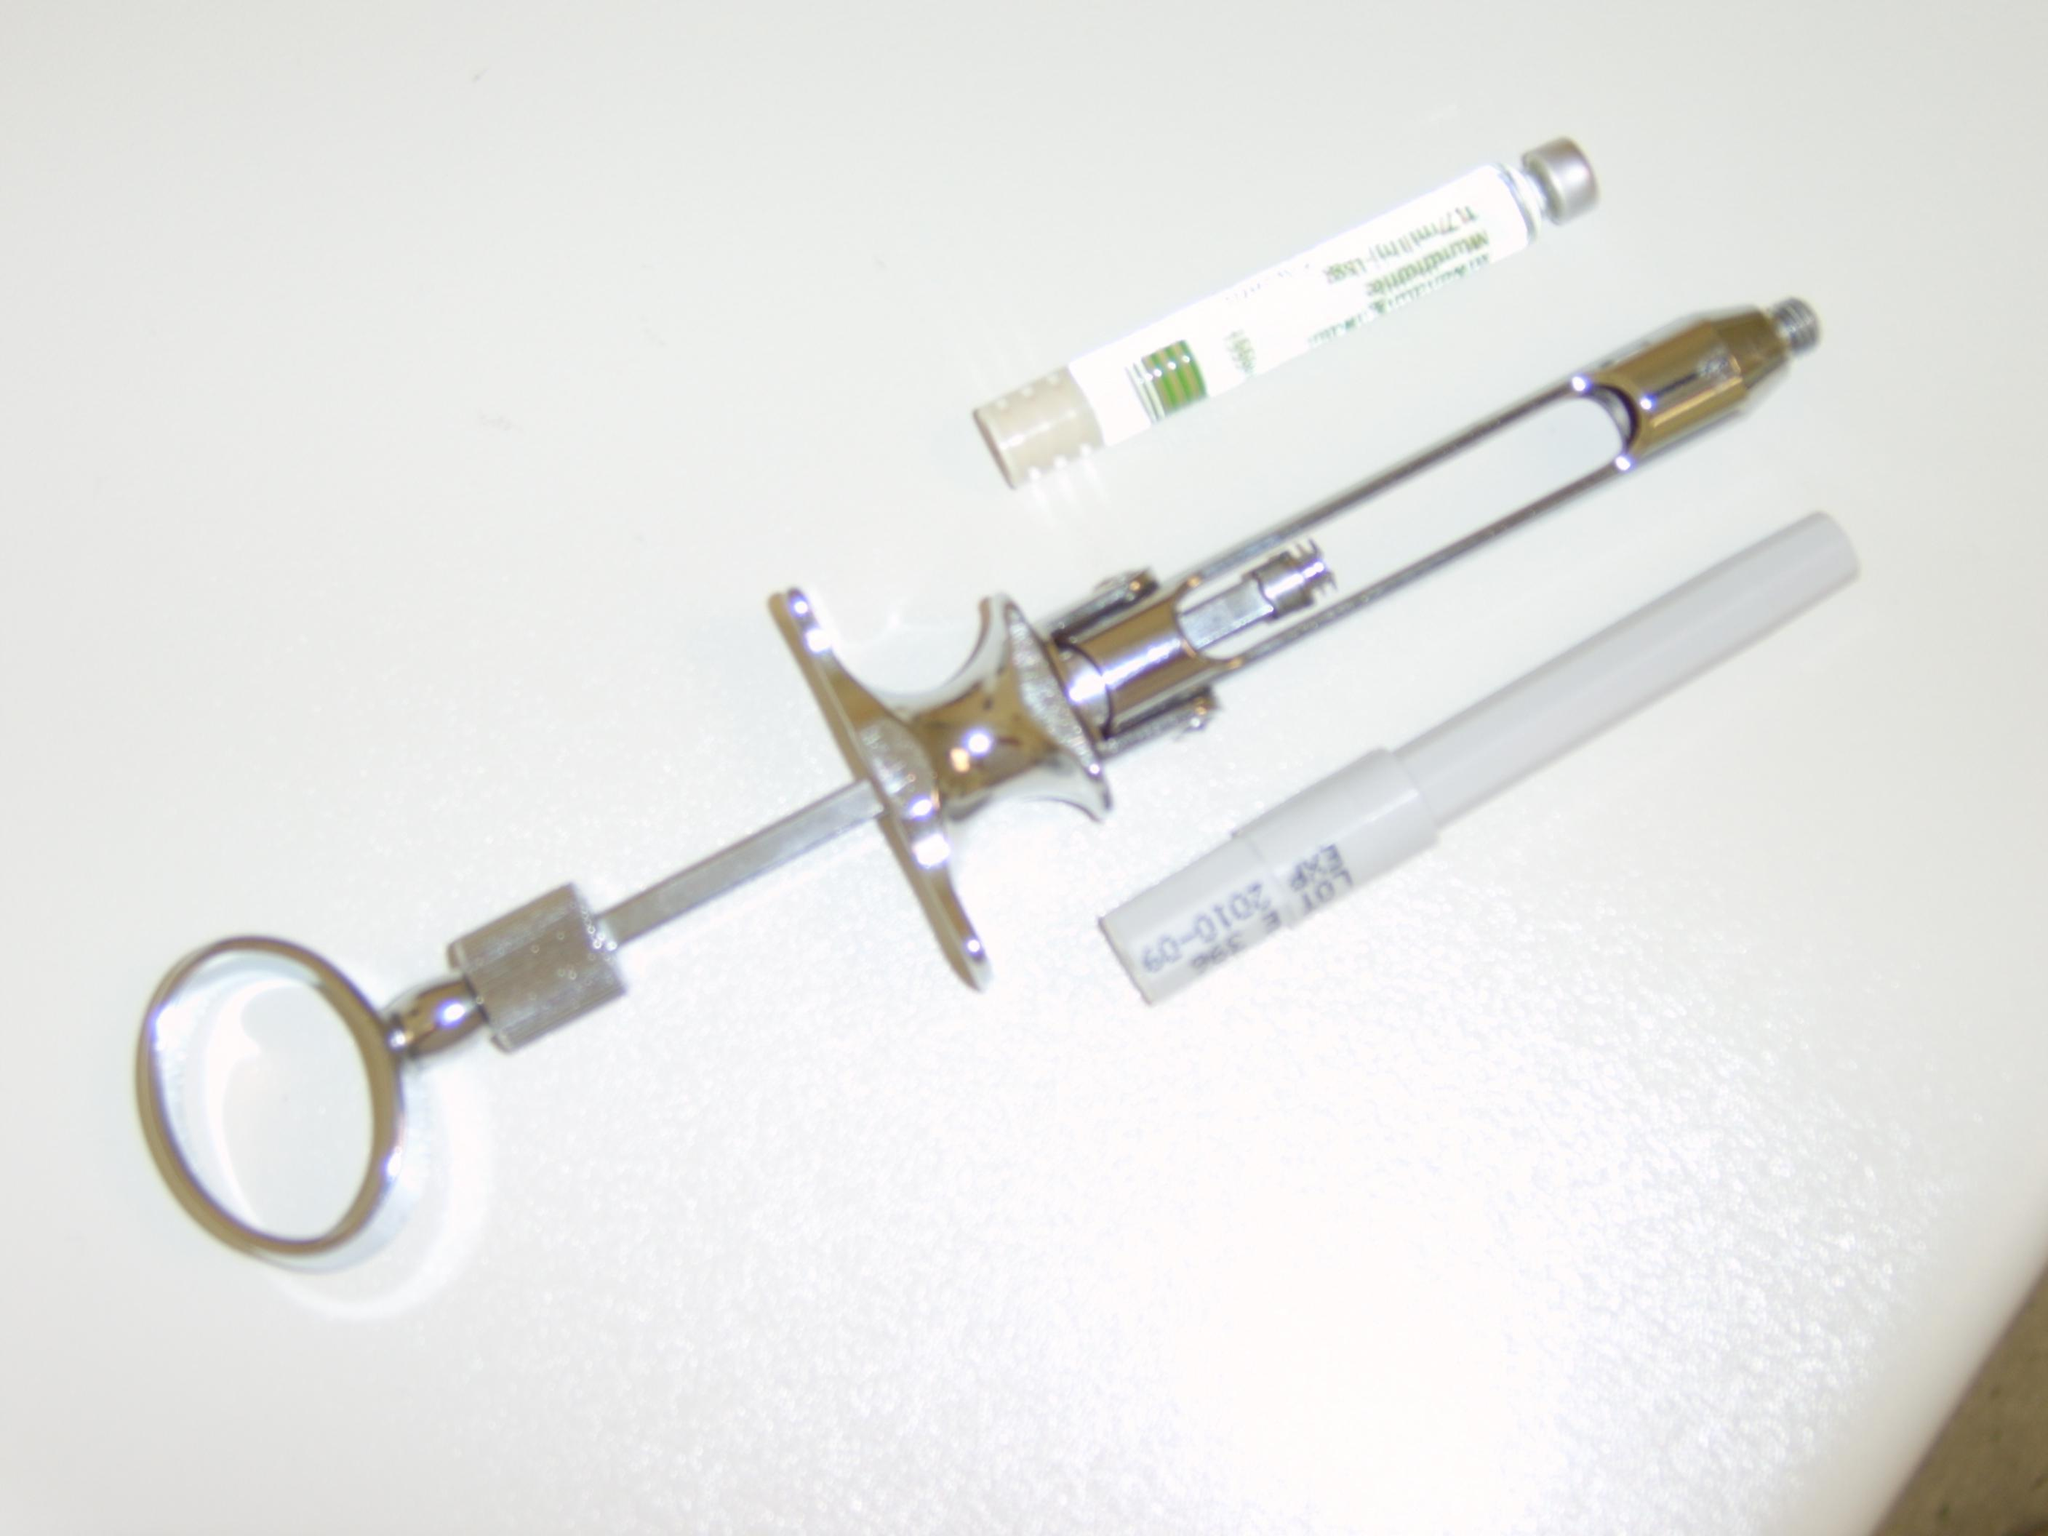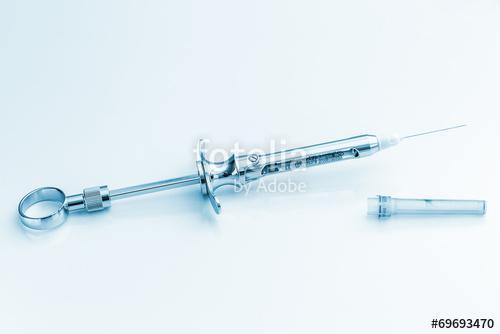The first image is the image on the left, the second image is the image on the right. For the images shown, is this caption "An image features exactly one syringe with an exposed needle tip." true? Answer yes or no. Yes. The first image is the image on the left, the second image is the image on the right. Evaluate the accuracy of this statement regarding the images: "There are four or more syringes in total.". Is it true? Answer yes or no. No. 